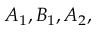<formula> <loc_0><loc_0><loc_500><loc_500>A _ { 1 } , B _ { 1 } , A _ { 2 } ,</formula> 